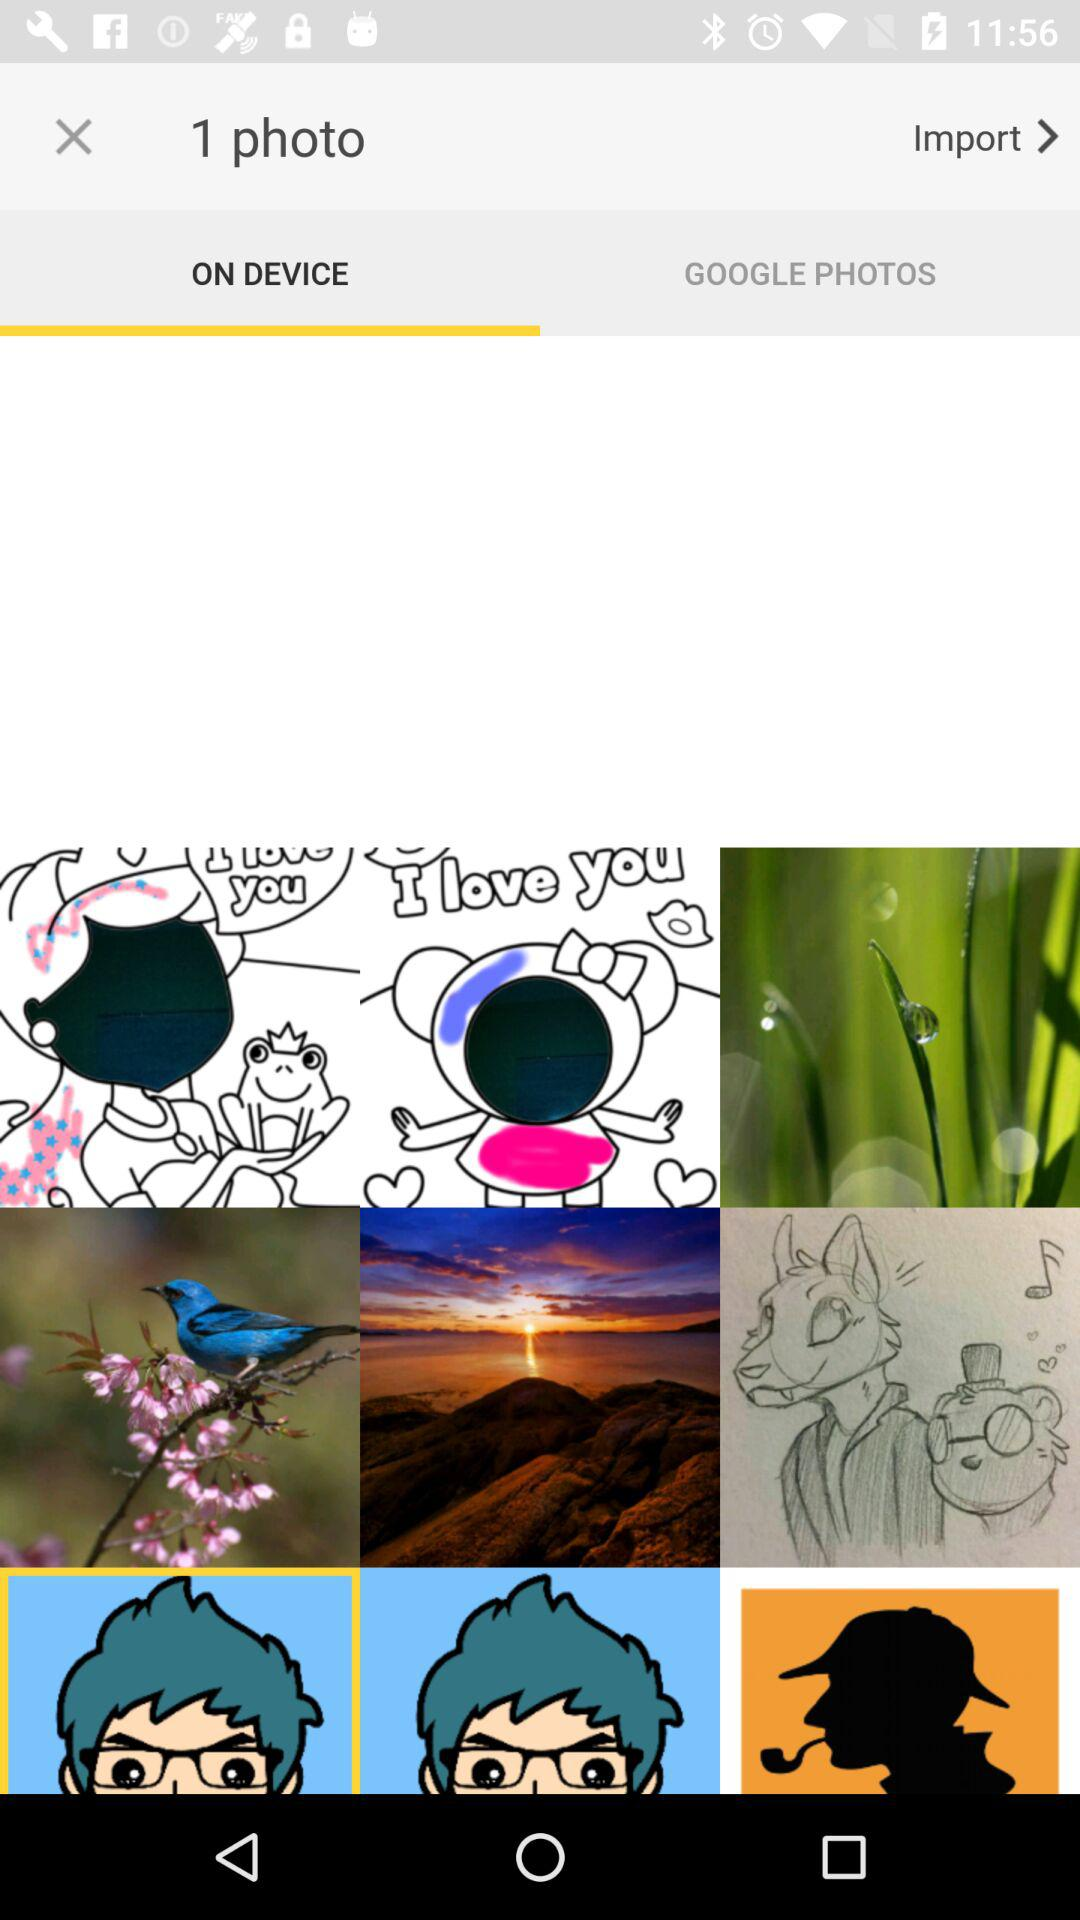Which is the selected tab? The selected tab is "ON DEVICE". 